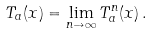Convert formula to latex. <formula><loc_0><loc_0><loc_500><loc_500>T _ { a } ( x ) = \lim _ { n \to \infty } T _ { a } ^ { n } ( x ) \, .</formula> 